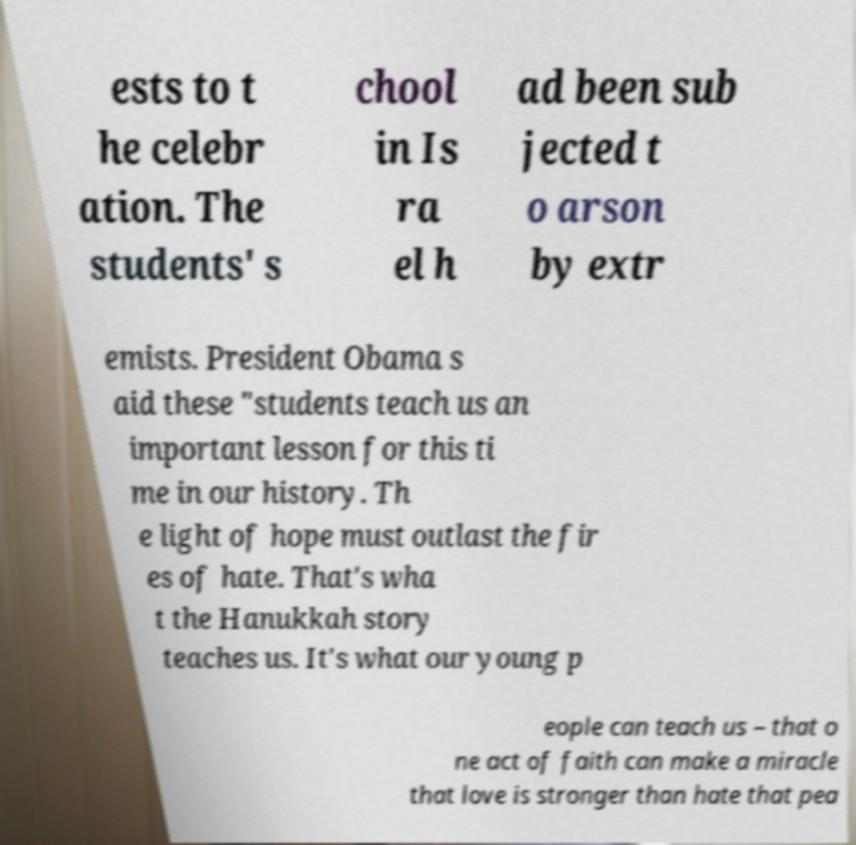There's text embedded in this image that I need extracted. Can you transcribe it verbatim? ests to t he celebr ation. The students' s chool in Is ra el h ad been sub jected t o arson by extr emists. President Obama s aid these "students teach us an important lesson for this ti me in our history. Th e light of hope must outlast the fir es of hate. That's wha t the Hanukkah story teaches us. It's what our young p eople can teach us – that o ne act of faith can make a miracle that love is stronger than hate that pea 